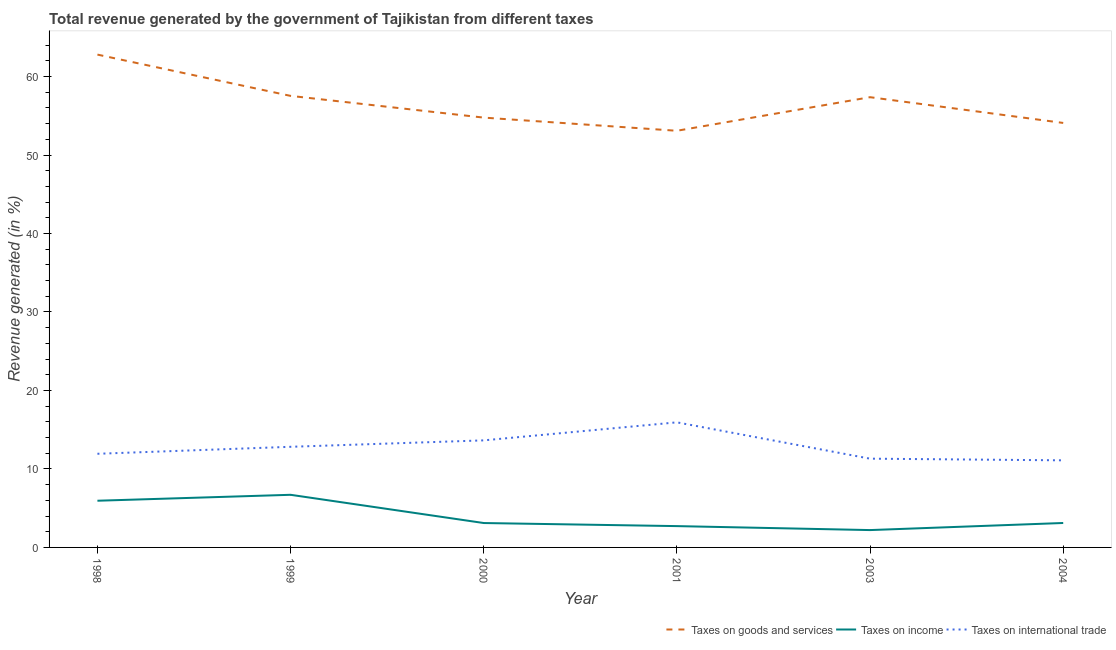What is the percentage of revenue generated by taxes on goods and services in 2004?
Provide a succinct answer. 54.09. Across all years, what is the maximum percentage of revenue generated by tax on international trade?
Ensure brevity in your answer.  15.94. Across all years, what is the minimum percentage of revenue generated by taxes on goods and services?
Offer a terse response. 53.09. In which year was the percentage of revenue generated by tax on international trade minimum?
Your answer should be very brief. 2004. What is the total percentage of revenue generated by tax on international trade in the graph?
Your response must be concise. 76.74. What is the difference between the percentage of revenue generated by taxes on income in 2001 and that in 2003?
Provide a short and direct response. 0.51. What is the difference between the percentage of revenue generated by tax on international trade in 2004 and the percentage of revenue generated by taxes on income in 1998?
Provide a succinct answer. 5.15. What is the average percentage of revenue generated by taxes on goods and services per year?
Make the answer very short. 56.61. In the year 2001, what is the difference between the percentage of revenue generated by tax on international trade and percentage of revenue generated by taxes on income?
Offer a terse response. 13.22. In how many years, is the percentage of revenue generated by taxes on goods and services greater than 54 %?
Give a very brief answer. 5. What is the ratio of the percentage of revenue generated by taxes on goods and services in 1998 to that in 1999?
Make the answer very short. 1.09. Is the percentage of revenue generated by taxes on income in 1998 less than that in 2000?
Provide a succinct answer. No. Is the difference between the percentage of revenue generated by taxes on income in 1998 and 2000 greater than the difference between the percentage of revenue generated by taxes on goods and services in 1998 and 2000?
Your answer should be compact. No. What is the difference between the highest and the second highest percentage of revenue generated by tax on international trade?
Your answer should be compact. 2.3. What is the difference between the highest and the lowest percentage of revenue generated by taxes on income?
Your response must be concise. 4.5. Is it the case that in every year, the sum of the percentage of revenue generated by taxes on goods and services and percentage of revenue generated by taxes on income is greater than the percentage of revenue generated by tax on international trade?
Provide a short and direct response. Yes. Does the percentage of revenue generated by tax on international trade monotonically increase over the years?
Keep it short and to the point. No. Is the percentage of revenue generated by taxes on income strictly less than the percentage of revenue generated by tax on international trade over the years?
Your answer should be very brief. Yes. How many years are there in the graph?
Give a very brief answer. 6. What is the difference between two consecutive major ticks on the Y-axis?
Your answer should be compact. 10. How many legend labels are there?
Give a very brief answer. 3. How are the legend labels stacked?
Ensure brevity in your answer.  Horizontal. What is the title of the graph?
Give a very brief answer. Total revenue generated by the government of Tajikistan from different taxes. What is the label or title of the Y-axis?
Your answer should be very brief. Revenue generated (in %). What is the Revenue generated (in %) of Taxes on goods and services in 1998?
Offer a terse response. 62.8. What is the Revenue generated (in %) of Taxes on income in 1998?
Provide a succinct answer. 5.95. What is the Revenue generated (in %) in Taxes on international trade in 1998?
Ensure brevity in your answer.  11.93. What is the Revenue generated (in %) in Taxes on goods and services in 1999?
Your answer should be compact. 57.54. What is the Revenue generated (in %) in Taxes on income in 1999?
Provide a short and direct response. 6.71. What is the Revenue generated (in %) in Taxes on international trade in 1999?
Provide a short and direct response. 12.82. What is the Revenue generated (in %) in Taxes on goods and services in 2000?
Provide a short and direct response. 54.77. What is the Revenue generated (in %) of Taxes on income in 2000?
Keep it short and to the point. 3.11. What is the Revenue generated (in %) of Taxes on international trade in 2000?
Keep it short and to the point. 13.64. What is the Revenue generated (in %) in Taxes on goods and services in 2001?
Provide a succinct answer. 53.09. What is the Revenue generated (in %) of Taxes on income in 2001?
Offer a very short reply. 2.72. What is the Revenue generated (in %) in Taxes on international trade in 2001?
Your response must be concise. 15.94. What is the Revenue generated (in %) of Taxes on goods and services in 2003?
Offer a very short reply. 57.37. What is the Revenue generated (in %) of Taxes on income in 2003?
Keep it short and to the point. 2.21. What is the Revenue generated (in %) in Taxes on international trade in 2003?
Your response must be concise. 11.31. What is the Revenue generated (in %) in Taxes on goods and services in 2004?
Ensure brevity in your answer.  54.09. What is the Revenue generated (in %) of Taxes on income in 2004?
Offer a terse response. 3.11. What is the Revenue generated (in %) of Taxes on international trade in 2004?
Offer a terse response. 11.1. Across all years, what is the maximum Revenue generated (in %) in Taxes on goods and services?
Give a very brief answer. 62.8. Across all years, what is the maximum Revenue generated (in %) in Taxes on income?
Offer a very short reply. 6.71. Across all years, what is the maximum Revenue generated (in %) of Taxes on international trade?
Give a very brief answer. 15.94. Across all years, what is the minimum Revenue generated (in %) of Taxes on goods and services?
Offer a terse response. 53.09. Across all years, what is the minimum Revenue generated (in %) in Taxes on income?
Ensure brevity in your answer.  2.21. Across all years, what is the minimum Revenue generated (in %) in Taxes on international trade?
Keep it short and to the point. 11.1. What is the total Revenue generated (in %) in Taxes on goods and services in the graph?
Keep it short and to the point. 339.66. What is the total Revenue generated (in %) in Taxes on income in the graph?
Give a very brief answer. 23.8. What is the total Revenue generated (in %) in Taxes on international trade in the graph?
Your response must be concise. 76.74. What is the difference between the Revenue generated (in %) of Taxes on goods and services in 1998 and that in 1999?
Offer a terse response. 5.26. What is the difference between the Revenue generated (in %) in Taxes on income in 1998 and that in 1999?
Give a very brief answer. -0.76. What is the difference between the Revenue generated (in %) of Taxes on international trade in 1998 and that in 1999?
Your answer should be very brief. -0.89. What is the difference between the Revenue generated (in %) in Taxes on goods and services in 1998 and that in 2000?
Provide a short and direct response. 8.03. What is the difference between the Revenue generated (in %) of Taxes on income in 1998 and that in 2000?
Offer a very short reply. 2.84. What is the difference between the Revenue generated (in %) in Taxes on international trade in 1998 and that in 2000?
Ensure brevity in your answer.  -1.71. What is the difference between the Revenue generated (in %) of Taxes on goods and services in 1998 and that in 2001?
Keep it short and to the point. 9.71. What is the difference between the Revenue generated (in %) of Taxes on income in 1998 and that in 2001?
Keep it short and to the point. 3.23. What is the difference between the Revenue generated (in %) in Taxes on international trade in 1998 and that in 2001?
Provide a short and direct response. -4.01. What is the difference between the Revenue generated (in %) of Taxes on goods and services in 1998 and that in 2003?
Ensure brevity in your answer.  5.43. What is the difference between the Revenue generated (in %) in Taxes on income in 1998 and that in 2003?
Ensure brevity in your answer.  3.74. What is the difference between the Revenue generated (in %) of Taxes on international trade in 1998 and that in 2003?
Your answer should be very brief. 0.62. What is the difference between the Revenue generated (in %) in Taxes on goods and services in 1998 and that in 2004?
Provide a short and direct response. 8.71. What is the difference between the Revenue generated (in %) of Taxes on income in 1998 and that in 2004?
Keep it short and to the point. 2.84. What is the difference between the Revenue generated (in %) of Taxes on international trade in 1998 and that in 2004?
Your answer should be compact. 0.83. What is the difference between the Revenue generated (in %) of Taxes on goods and services in 1999 and that in 2000?
Make the answer very short. 2.77. What is the difference between the Revenue generated (in %) in Taxes on income in 1999 and that in 2000?
Keep it short and to the point. 3.6. What is the difference between the Revenue generated (in %) in Taxes on international trade in 1999 and that in 2000?
Make the answer very short. -0.82. What is the difference between the Revenue generated (in %) in Taxes on goods and services in 1999 and that in 2001?
Your answer should be compact. 4.45. What is the difference between the Revenue generated (in %) of Taxes on income in 1999 and that in 2001?
Make the answer very short. 3.99. What is the difference between the Revenue generated (in %) in Taxes on international trade in 1999 and that in 2001?
Your answer should be compact. -3.12. What is the difference between the Revenue generated (in %) of Taxes on goods and services in 1999 and that in 2003?
Provide a short and direct response. 0.17. What is the difference between the Revenue generated (in %) in Taxes on income in 1999 and that in 2003?
Offer a very short reply. 4.5. What is the difference between the Revenue generated (in %) of Taxes on international trade in 1999 and that in 2003?
Keep it short and to the point. 1.51. What is the difference between the Revenue generated (in %) in Taxes on goods and services in 1999 and that in 2004?
Offer a terse response. 3.45. What is the difference between the Revenue generated (in %) in Taxes on income in 1999 and that in 2004?
Your answer should be compact. 3.59. What is the difference between the Revenue generated (in %) in Taxes on international trade in 1999 and that in 2004?
Give a very brief answer. 1.72. What is the difference between the Revenue generated (in %) of Taxes on goods and services in 2000 and that in 2001?
Offer a very short reply. 1.68. What is the difference between the Revenue generated (in %) of Taxes on income in 2000 and that in 2001?
Provide a short and direct response. 0.39. What is the difference between the Revenue generated (in %) of Taxes on international trade in 2000 and that in 2001?
Your answer should be compact. -2.3. What is the difference between the Revenue generated (in %) in Taxes on goods and services in 2000 and that in 2003?
Your answer should be very brief. -2.6. What is the difference between the Revenue generated (in %) of Taxes on income in 2000 and that in 2003?
Provide a succinct answer. 0.9. What is the difference between the Revenue generated (in %) of Taxes on international trade in 2000 and that in 2003?
Your answer should be compact. 2.33. What is the difference between the Revenue generated (in %) in Taxes on goods and services in 2000 and that in 2004?
Give a very brief answer. 0.68. What is the difference between the Revenue generated (in %) in Taxes on income in 2000 and that in 2004?
Provide a short and direct response. -0. What is the difference between the Revenue generated (in %) in Taxes on international trade in 2000 and that in 2004?
Keep it short and to the point. 2.54. What is the difference between the Revenue generated (in %) of Taxes on goods and services in 2001 and that in 2003?
Keep it short and to the point. -4.28. What is the difference between the Revenue generated (in %) of Taxes on income in 2001 and that in 2003?
Ensure brevity in your answer.  0.51. What is the difference between the Revenue generated (in %) of Taxes on international trade in 2001 and that in 2003?
Your answer should be very brief. 4.63. What is the difference between the Revenue generated (in %) in Taxes on goods and services in 2001 and that in 2004?
Give a very brief answer. -1. What is the difference between the Revenue generated (in %) in Taxes on income in 2001 and that in 2004?
Provide a succinct answer. -0.4. What is the difference between the Revenue generated (in %) of Taxes on international trade in 2001 and that in 2004?
Give a very brief answer. 4.84. What is the difference between the Revenue generated (in %) in Taxes on goods and services in 2003 and that in 2004?
Make the answer very short. 3.28. What is the difference between the Revenue generated (in %) in Taxes on income in 2003 and that in 2004?
Ensure brevity in your answer.  -0.9. What is the difference between the Revenue generated (in %) of Taxes on international trade in 2003 and that in 2004?
Make the answer very short. 0.21. What is the difference between the Revenue generated (in %) of Taxes on goods and services in 1998 and the Revenue generated (in %) of Taxes on income in 1999?
Keep it short and to the point. 56.09. What is the difference between the Revenue generated (in %) of Taxes on goods and services in 1998 and the Revenue generated (in %) of Taxes on international trade in 1999?
Provide a short and direct response. 49.98. What is the difference between the Revenue generated (in %) in Taxes on income in 1998 and the Revenue generated (in %) in Taxes on international trade in 1999?
Offer a very short reply. -6.87. What is the difference between the Revenue generated (in %) of Taxes on goods and services in 1998 and the Revenue generated (in %) of Taxes on income in 2000?
Your answer should be very brief. 59.69. What is the difference between the Revenue generated (in %) in Taxes on goods and services in 1998 and the Revenue generated (in %) in Taxes on international trade in 2000?
Ensure brevity in your answer.  49.16. What is the difference between the Revenue generated (in %) of Taxes on income in 1998 and the Revenue generated (in %) of Taxes on international trade in 2000?
Keep it short and to the point. -7.69. What is the difference between the Revenue generated (in %) of Taxes on goods and services in 1998 and the Revenue generated (in %) of Taxes on income in 2001?
Give a very brief answer. 60.08. What is the difference between the Revenue generated (in %) in Taxes on goods and services in 1998 and the Revenue generated (in %) in Taxes on international trade in 2001?
Your response must be concise. 46.86. What is the difference between the Revenue generated (in %) in Taxes on income in 1998 and the Revenue generated (in %) in Taxes on international trade in 2001?
Your answer should be compact. -9.99. What is the difference between the Revenue generated (in %) in Taxes on goods and services in 1998 and the Revenue generated (in %) in Taxes on income in 2003?
Your answer should be very brief. 60.59. What is the difference between the Revenue generated (in %) in Taxes on goods and services in 1998 and the Revenue generated (in %) in Taxes on international trade in 2003?
Your answer should be compact. 51.49. What is the difference between the Revenue generated (in %) in Taxes on income in 1998 and the Revenue generated (in %) in Taxes on international trade in 2003?
Your response must be concise. -5.36. What is the difference between the Revenue generated (in %) in Taxes on goods and services in 1998 and the Revenue generated (in %) in Taxes on income in 2004?
Provide a succinct answer. 59.68. What is the difference between the Revenue generated (in %) of Taxes on goods and services in 1998 and the Revenue generated (in %) of Taxes on international trade in 2004?
Your answer should be compact. 51.7. What is the difference between the Revenue generated (in %) of Taxes on income in 1998 and the Revenue generated (in %) of Taxes on international trade in 2004?
Your response must be concise. -5.15. What is the difference between the Revenue generated (in %) in Taxes on goods and services in 1999 and the Revenue generated (in %) in Taxes on income in 2000?
Your response must be concise. 54.43. What is the difference between the Revenue generated (in %) in Taxes on goods and services in 1999 and the Revenue generated (in %) in Taxes on international trade in 2000?
Keep it short and to the point. 43.9. What is the difference between the Revenue generated (in %) of Taxes on income in 1999 and the Revenue generated (in %) of Taxes on international trade in 2000?
Give a very brief answer. -6.94. What is the difference between the Revenue generated (in %) of Taxes on goods and services in 1999 and the Revenue generated (in %) of Taxes on income in 2001?
Keep it short and to the point. 54.82. What is the difference between the Revenue generated (in %) in Taxes on goods and services in 1999 and the Revenue generated (in %) in Taxes on international trade in 2001?
Ensure brevity in your answer.  41.6. What is the difference between the Revenue generated (in %) of Taxes on income in 1999 and the Revenue generated (in %) of Taxes on international trade in 2001?
Your answer should be very brief. -9.23. What is the difference between the Revenue generated (in %) of Taxes on goods and services in 1999 and the Revenue generated (in %) of Taxes on income in 2003?
Your answer should be very brief. 55.33. What is the difference between the Revenue generated (in %) of Taxes on goods and services in 1999 and the Revenue generated (in %) of Taxes on international trade in 2003?
Make the answer very short. 46.23. What is the difference between the Revenue generated (in %) in Taxes on income in 1999 and the Revenue generated (in %) in Taxes on international trade in 2003?
Your answer should be very brief. -4.6. What is the difference between the Revenue generated (in %) in Taxes on goods and services in 1999 and the Revenue generated (in %) in Taxes on income in 2004?
Make the answer very short. 54.42. What is the difference between the Revenue generated (in %) of Taxes on goods and services in 1999 and the Revenue generated (in %) of Taxes on international trade in 2004?
Your answer should be compact. 46.44. What is the difference between the Revenue generated (in %) in Taxes on income in 1999 and the Revenue generated (in %) in Taxes on international trade in 2004?
Make the answer very short. -4.39. What is the difference between the Revenue generated (in %) of Taxes on goods and services in 2000 and the Revenue generated (in %) of Taxes on income in 2001?
Provide a short and direct response. 52.05. What is the difference between the Revenue generated (in %) of Taxes on goods and services in 2000 and the Revenue generated (in %) of Taxes on international trade in 2001?
Give a very brief answer. 38.83. What is the difference between the Revenue generated (in %) of Taxes on income in 2000 and the Revenue generated (in %) of Taxes on international trade in 2001?
Your response must be concise. -12.83. What is the difference between the Revenue generated (in %) of Taxes on goods and services in 2000 and the Revenue generated (in %) of Taxes on income in 2003?
Provide a short and direct response. 52.56. What is the difference between the Revenue generated (in %) of Taxes on goods and services in 2000 and the Revenue generated (in %) of Taxes on international trade in 2003?
Keep it short and to the point. 43.46. What is the difference between the Revenue generated (in %) in Taxes on income in 2000 and the Revenue generated (in %) in Taxes on international trade in 2003?
Make the answer very short. -8.2. What is the difference between the Revenue generated (in %) in Taxes on goods and services in 2000 and the Revenue generated (in %) in Taxes on income in 2004?
Provide a short and direct response. 51.65. What is the difference between the Revenue generated (in %) of Taxes on goods and services in 2000 and the Revenue generated (in %) of Taxes on international trade in 2004?
Your answer should be compact. 43.67. What is the difference between the Revenue generated (in %) in Taxes on income in 2000 and the Revenue generated (in %) in Taxes on international trade in 2004?
Your answer should be compact. -7.99. What is the difference between the Revenue generated (in %) of Taxes on goods and services in 2001 and the Revenue generated (in %) of Taxes on income in 2003?
Ensure brevity in your answer.  50.88. What is the difference between the Revenue generated (in %) in Taxes on goods and services in 2001 and the Revenue generated (in %) in Taxes on international trade in 2003?
Provide a succinct answer. 41.78. What is the difference between the Revenue generated (in %) in Taxes on income in 2001 and the Revenue generated (in %) in Taxes on international trade in 2003?
Ensure brevity in your answer.  -8.59. What is the difference between the Revenue generated (in %) of Taxes on goods and services in 2001 and the Revenue generated (in %) of Taxes on income in 2004?
Your answer should be compact. 49.98. What is the difference between the Revenue generated (in %) in Taxes on goods and services in 2001 and the Revenue generated (in %) in Taxes on international trade in 2004?
Offer a terse response. 41.99. What is the difference between the Revenue generated (in %) of Taxes on income in 2001 and the Revenue generated (in %) of Taxes on international trade in 2004?
Your answer should be very brief. -8.38. What is the difference between the Revenue generated (in %) of Taxes on goods and services in 2003 and the Revenue generated (in %) of Taxes on income in 2004?
Your answer should be compact. 54.26. What is the difference between the Revenue generated (in %) in Taxes on goods and services in 2003 and the Revenue generated (in %) in Taxes on international trade in 2004?
Ensure brevity in your answer.  46.27. What is the difference between the Revenue generated (in %) in Taxes on income in 2003 and the Revenue generated (in %) in Taxes on international trade in 2004?
Provide a succinct answer. -8.89. What is the average Revenue generated (in %) of Taxes on goods and services per year?
Provide a short and direct response. 56.61. What is the average Revenue generated (in %) of Taxes on income per year?
Keep it short and to the point. 3.97. What is the average Revenue generated (in %) of Taxes on international trade per year?
Provide a short and direct response. 12.79. In the year 1998, what is the difference between the Revenue generated (in %) of Taxes on goods and services and Revenue generated (in %) of Taxes on income?
Offer a terse response. 56.85. In the year 1998, what is the difference between the Revenue generated (in %) of Taxes on goods and services and Revenue generated (in %) of Taxes on international trade?
Your answer should be compact. 50.87. In the year 1998, what is the difference between the Revenue generated (in %) in Taxes on income and Revenue generated (in %) in Taxes on international trade?
Provide a succinct answer. -5.98. In the year 1999, what is the difference between the Revenue generated (in %) of Taxes on goods and services and Revenue generated (in %) of Taxes on income?
Keep it short and to the point. 50.83. In the year 1999, what is the difference between the Revenue generated (in %) in Taxes on goods and services and Revenue generated (in %) in Taxes on international trade?
Offer a very short reply. 44.72. In the year 1999, what is the difference between the Revenue generated (in %) of Taxes on income and Revenue generated (in %) of Taxes on international trade?
Make the answer very short. -6.12. In the year 2000, what is the difference between the Revenue generated (in %) of Taxes on goods and services and Revenue generated (in %) of Taxes on income?
Your answer should be very brief. 51.66. In the year 2000, what is the difference between the Revenue generated (in %) in Taxes on goods and services and Revenue generated (in %) in Taxes on international trade?
Offer a terse response. 41.13. In the year 2000, what is the difference between the Revenue generated (in %) of Taxes on income and Revenue generated (in %) of Taxes on international trade?
Provide a short and direct response. -10.53. In the year 2001, what is the difference between the Revenue generated (in %) of Taxes on goods and services and Revenue generated (in %) of Taxes on income?
Keep it short and to the point. 50.37. In the year 2001, what is the difference between the Revenue generated (in %) of Taxes on goods and services and Revenue generated (in %) of Taxes on international trade?
Keep it short and to the point. 37.15. In the year 2001, what is the difference between the Revenue generated (in %) of Taxes on income and Revenue generated (in %) of Taxes on international trade?
Provide a short and direct response. -13.22. In the year 2003, what is the difference between the Revenue generated (in %) of Taxes on goods and services and Revenue generated (in %) of Taxes on income?
Provide a succinct answer. 55.16. In the year 2003, what is the difference between the Revenue generated (in %) of Taxes on goods and services and Revenue generated (in %) of Taxes on international trade?
Your answer should be very brief. 46.06. In the year 2003, what is the difference between the Revenue generated (in %) in Taxes on income and Revenue generated (in %) in Taxes on international trade?
Ensure brevity in your answer.  -9.1. In the year 2004, what is the difference between the Revenue generated (in %) in Taxes on goods and services and Revenue generated (in %) in Taxes on income?
Your answer should be compact. 50.98. In the year 2004, what is the difference between the Revenue generated (in %) of Taxes on goods and services and Revenue generated (in %) of Taxes on international trade?
Provide a short and direct response. 42.99. In the year 2004, what is the difference between the Revenue generated (in %) of Taxes on income and Revenue generated (in %) of Taxes on international trade?
Keep it short and to the point. -7.98. What is the ratio of the Revenue generated (in %) of Taxes on goods and services in 1998 to that in 1999?
Keep it short and to the point. 1.09. What is the ratio of the Revenue generated (in %) in Taxes on income in 1998 to that in 1999?
Ensure brevity in your answer.  0.89. What is the ratio of the Revenue generated (in %) of Taxes on international trade in 1998 to that in 1999?
Keep it short and to the point. 0.93. What is the ratio of the Revenue generated (in %) in Taxes on goods and services in 1998 to that in 2000?
Your answer should be compact. 1.15. What is the ratio of the Revenue generated (in %) of Taxes on income in 1998 to that in 2000?
Keep it short and to the point. 1.91. What is the ratio of the Revenue generated (in %) in Taxes on international trade in 1998 to that in 2000?
Keep it short and to the point. 0.87. What is the ratio of the Revenue generated (in %) of Taxes on goods and services in 1998 to that in 2001?
Offer a terse response. 1.18. What is the ratio of the Revenue generated (in %) of Taxes on income in 1998 to that in 2001?
Make the answer very short. 2.19. What is the ratio of the Revenue generated (in %) of Taxes on international trade in 1998 to that in 2001?
Make the answer very short. 0.75. What is the ratio of the Revenue generated (in %) of Taxes on goods and services in 1998 to that in 2003?
Offer a terse response. 1.09. What is the ratio of the Revenue generated (in %) in Taxes on income in 1998 to that in 2003?
Offer a terse response. 2.69. What is the ratio of the Revenue generated (in %) of Taxes on international trade in 1998 to that in 2003?
Make the answer very short. 1.05. What is the ratio of the Revenue generated (in %) in Taxes on goods and services in 1998 to that in 2004?
Your response must be concise. 1.16. What is the ratio of the Revenue generated (in %) in Taxes on income in 1998 to that in 2004?
Offer a very short reply. 1.91. What is the ratio of the Revenue generated (in %) of Taxes on international trade in 1998 to that in 2004?
Offer a terse response. 1.08. What is the ratio of the Revenue generated (in %) in Taxes on goods and services in 1999 to that in 2000?
Keep it short and to the point. 1.05. What is the ratio of the Revenue generated (in %) in Taxes on income in 1999 to that in 2000?
Your answer should be compact. 2.16. What is the ratio of the Revenue generated (in %) of Taxes on international trade in 1999 to that in 2000?
Provide a short and direct response. 0.94. What is the ratio of the Revenue generated (in %) of Taxes on goods and services in 1999 to that in 2001?
Give a very brief answer. 1.08. What is the ratio of the Revenue generated (in %) in Taxes on income in 1999 to that in 2001?
Provide a succinct answer. 2.47. What is the ratio of the Revenue generated (in %) in Taxes on international trade in 1999 to that in 2001?
Keep it short and to the point. 0.8. What is the ratio of the Revenue generated (in %) in Taxes on goods and services in 1999 to that in 2003?
Provide a short and direct response. 1. What is the ratio of the Revenue generated (in %) of Taxes on income in 1999 to that in 2003?
Your answer should be compact. 3.03. What is the ratio of the Revenue generated (in %) of Taxes on international trade in 1999 to that in 2003?
Provide a succinct answer. 1.13. What is the ratio of the Revenue generated (in %) of Taxes on goods and services in 1999 to that in 2004?
Offer a terse response. 1.06. What is the ratio of the Revenue generated (in %) of Taxes on income in 1999 to that in 2004?
Your answer should be very brief. 2.15. What is the ratio of the Revenue generated (in %) in Taxes on international trade in 1999 to that in 2004?
Give a very brief answer. 1.16. What is the ratio of the Revenue generated (in %) of Taxes on goods and services in 2000 to that in 2001?
Your answer should be very brief. 1.03. What is the ratio of the Revenue generated (in %) in Taxes on income in 2000 to that in 2001?
Keep it short and to the point. 1.14. What is the ratio of the Revenue generated (in %) in Taxes on international trade in 2000 to that in 2001?
Your response must be concise. 0.86. What is the ratio of the Revenue generated (in %) of Taxes on goods and services in 2000 to that in 2003?
Provide a succinct answer. 0.95. What is the ratio of the Revenue generated (in %) in Taxes on income in 2000 to that in 2003?
Offer a very short reply. 1.41. What is the ratio of the Revenue generated (in %) of Taxes on international trade in 2000 to that in 2003?
Provide a succinct answer. 1.21. What is the ratio of the Revenue generated (in %) of Taxes on goods and services in 2000 to that in 2004?
Offer a terse response. 1.01. What is the ratio of the Revenue generated (in %) of Taxes on income in 2000 to that in 2004?
Your response must be concise. 1. What is the ratio of the Revenue generated (in %) of Taxes on international trade in 2000 to that in 2004?
Your answer should be compact. 1.23. What is the ratio of the Revenue generated (in %) of Taxes on goods and services in 2001 to that in 2003?
Offer a terse response. 0.93. What is the ratio of the Revenue generated (in %) of Taxes on income in 2001 to that in 2003?
Offer a terse response. 1.23. What is the ratio of the Revenue generated (in %) of Taxes on international trade in 2001 to that in 2003?
Make the answer very short. 1.41. What is the ratio of the Revenue generated (in %) of Taxes on goods and services in 2001 to that in 2004?
Give a very brief answer. 0.98. What is the ratio of the Revenue generated (in %) of Taxes on income in 2001 to that in 2004?
Your answer should be very brief. 0.87. What is the ratio of the Revenue generated (in %) in Taxes on international trade in 2001 to that in 2004?
Your response must be concise. 1.44. What is the ratio of the Revenue generated (in %) in Taxes on goods and services in 2003 to that in 2004?
Keep it short and to the point. 1.06. What is the ratio of the Revenue generated (in %) in Taxes on income in 2003 to that in 2004?
Offer a very short reply. 0.71. What is the ratio of the Revenue generated (in %) in Taxes on international trade in 2003 to that in 2004?
Provide a short and direct response. 1.02. What is the difference between the highest and the second highest Revenue generated (in %) of Taxes on goods and services?
Keep it short and to the point. 5.26. What is the difference between the highest and the second highest Revenue generated (in %) of Taxes on income?
Offer a very short reply. 0.76. What is the difference between the highest and the second highest Revenue generated (in %) in Taxes on international trade?
Offer a very short reply. 2.3. What is the difference between the highest and the lowest Revenue generated (in %) of Taxes on goods and services?
Provide a succinct answer. 9.71. What is the difference between the highest and the lowest Revenue generated (in %) in Taxes on income?
Ensure brevity in your answer.  4.5. What is the difference between the highest and the lowest Revenue generated (in %) in Taxes on international trade?
Ensure brevity in your answer.  4.84. 